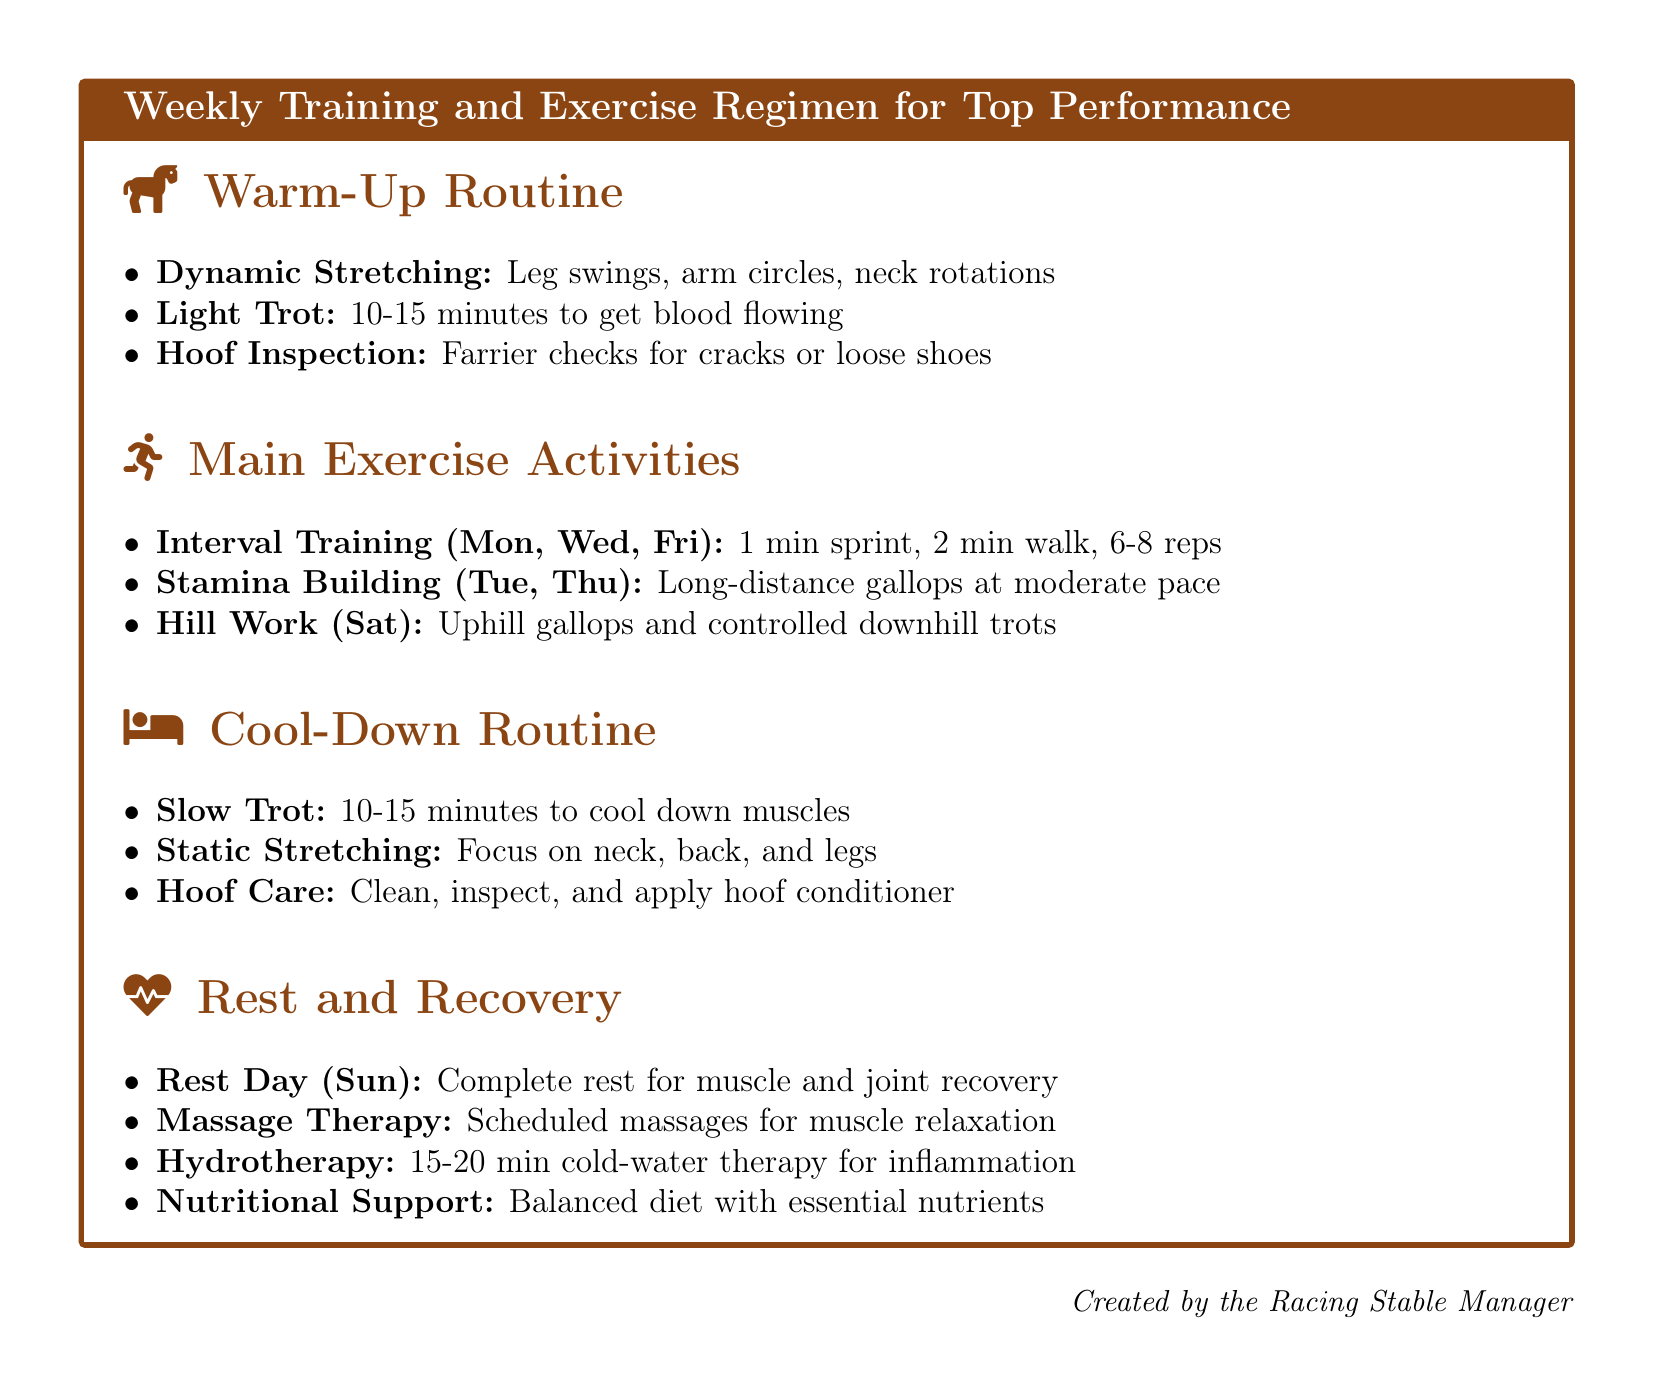What is the warm-up activity that includes leg swings? Dynamic Stretching is listed as one of the warm-up activities including leg swings.
Answer: Dynamic Stretching How long should the light trot last? The light trot is recommended to last for 10-15 minutes to get blood flowing.
Answer: 10-15 minutes On which days is interval training scheduled? Interval training is scheduled for Monday, Wednesday, and Friday according to the document.
Answer: Mon, Wed, Fri What is included in the cool-down routine for hoof care? The cool-down routine for hoof care involves cleaning, inspecting, and applying hoof conditioner.
Answer: Clean, inspect, and apply hoof conditioner How long should hydrotherapy last? Hydrotherapy is suggested to last for 15-20 minutes for inflammation treatment.
Answer: 15-20 minutes What type of exercise is scheduled for Tuesday and Thursday? Stamina building, which involves long-distance gallops at a moderate pace, is scheduled for these days.
Answer: Long-distance gallops What is the purpose of the slow trot in the cool-down routine? The slow trot is intended to cool down the muscles after main exercise activities.
Answer: Cool down muscles What is a scheduled activity on Sundays? A complete rest day is scheduled for Sundays to aid in muscle and joint recovery.
Answer: Complete rest How many reps are involved in interval training? Interval training involves 6-8 repetitions as specified in the document.
Answer: 6-8 reps 